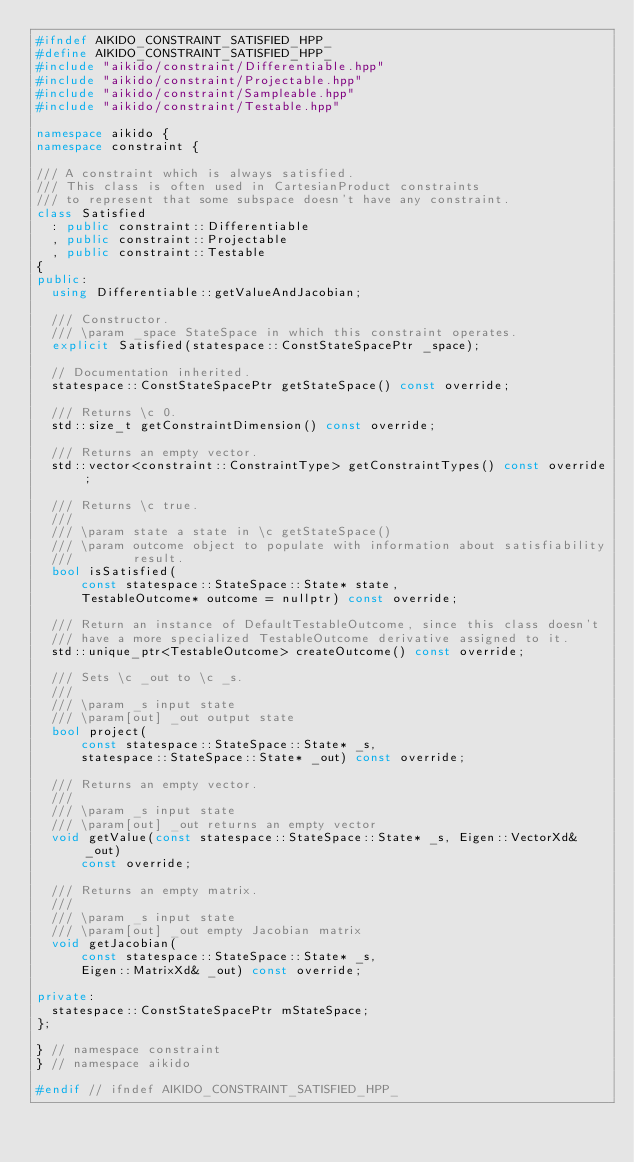<code> <loc_0><loc_0><loc_500><loc_500><_C++_>#ifndef AIKIDO_CONSTRAINT_SATISFIED_HPP_
#define AIKIDO_CONSTRAINT_SATISFIED_HPP_
#include "aikido/constraint/Differentiable.hpp"
#include "aikido/constraint/Projectable.hpp"
#include "aikido/constraint/Sampleable.hpp"
#include "aikido/constraint/Testable.hpp"

namespace aikido {
namespace constraint {

/// A constraint which is always satisfied.
/// This class is often used in CartesianProduct constraints
/// to represent that some subspace doesn't have any constraint.
class Satisfied
  : public constraint::Differentiable
  , public constraint::Projectable
  , public constraint::Testable
{
public:
  using Differentiable::getValueAndJacobian;

  /// Constructor.
  /// \param _space StateSpace in which this constraint operates.
  explicit Satisfied(statespace::ConstStateSpacePtr _space);

  // Documentation inherited.
  statespace::ConstStateSpacePtr getStateSpace() const override;

  /// Returns \c 0.
  std::size_t getConstraintDimension() const override;

  /// Returns an empty vector.
  std::vector<constraint::ConstraintType> getConstraintTypes() const override;

  /// Returns \c true.
  ///
  /// \param state a state in \c getStateSpace()
  /// \param outcome object to populate with information about satisfiability
  ///        result.
  bool isSatisfied(
      const statespace::StateSpace::State* state,
      TestableOutcome* outcome = nullptr) const override;

  /// Return an instance of DefaultTestableOutcome, since this class doesn't
  /// have a more specialized TestableOutcome derivative assigned to it.
  std::unique_ptr<TestableOutcome> createOutcome() const override;

  /// Sets \c _out to \c _s.
  ///
  /// \param _s input state
  /// \param[out] _out output state
  bool project(
      const statespace::StateSpace::State* _s,
      statespace::StateSpace::State* _out) const override;

  /// Returns an empty vector.
  ///
  /// \param _s input state
  /// \param[out] _out returns an empty vector
  void getValue(const statespace::StateSpace::State* _s, Eigen::VectorXd& _out)
      const override;

  /// Returns an empty matrix.
  ///
  /// \param _s input state
  /// \param[out] _out empty Jacobian matrix
  void getJacobian(
      const statespace::StateSpace::State* _s,
      Eigen::MatrixXd& _out) const override;

private:
  statespace::ConstStateSpacePtr mStateSpace;
};

} // namespace constraint
} // namespace aikido

#endif // ifndef AIKIDO_CONSTRAINT_SATISFIED_HPP_
</code> 